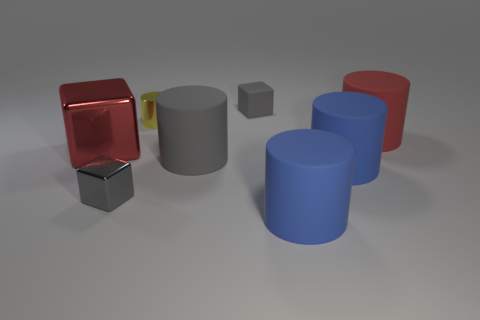Subtract all gray cylinders. How many cylinders are left? 4 Subtract all large red cylinders. How many cylinders are left? 4 Subtract 1 cylinders. How many cylinders are left? 4 Subtract all cyan cylinders. Subtract all gray blocks. How many cylinders are left? 5 Add 1 big gray cylinders. How many objects exist? 9 Subtract all blocks. How many objects are left? 5 Subtract all big matte cylinders. Subtract all blue matte objects. How many objects are left? 2 Add 1 big shiny blocks. How many big shiny blocks are left? 2 Add 4 large red shiny blocks. How many large red shiny blocks exist? 5 Subtract 0 cyan cylinders. How many objects are left? 8 